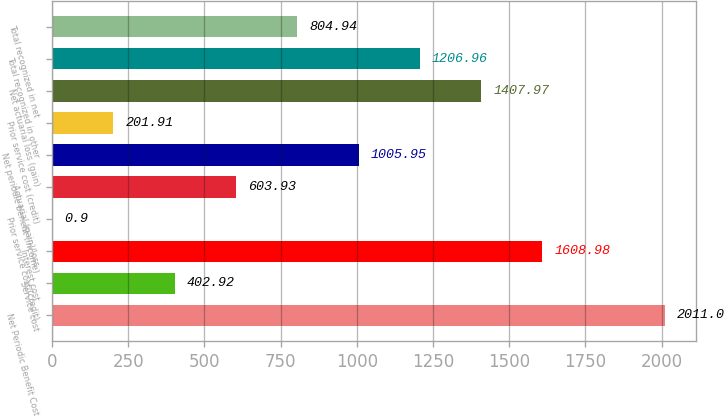Convert chart to OTSL. <chart><loc_0><loc_0><loc_500><loc_500><bar_chart><fcel>Net Periodic Benefit Cost<fcel>Service cost<fcel>Interest cost<fcel>Prior service cost/(credit)<fcel>Actuarial (gain)/loss<fcel>Net periodic benefit (income)<fcel>Prior service cost (credit)<fcel>Net actuarial loss (gain)<fcel>Total recognized in other<fcel>Total recognized in net<nl><fcel>2011<fcel>402.92<fcel>1608.98<fcel>0.9<fcel>603.93<fcel>1005.95<fcel>201.91<fcel>1407.97<fcel>1206.96<fcel>804.94<nl></chart> 